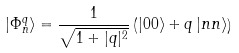Convert formula to latex. <formula><loc_0><loc_0><loc_500><loc_500>| \Phi _ { n } ^ { q } \rangle = \frac { 1 } { \sqrt { 1 + | q | ^ { 2 } } } \left ( | 0 0 \rangle + q \, | n n \rangle \right )</formula> 